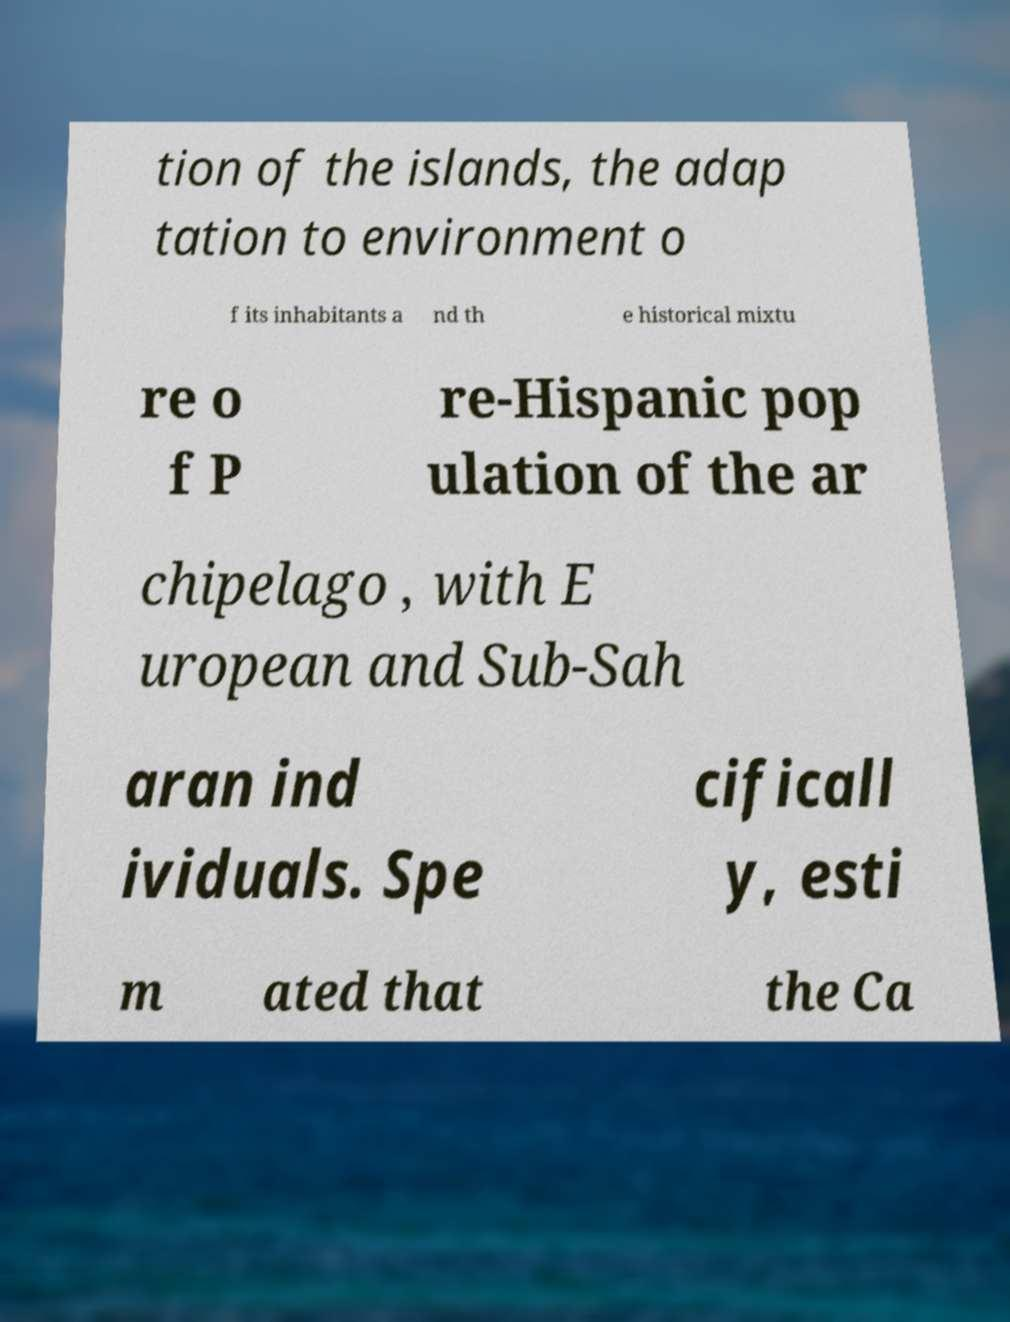I need the written content from this picture converted into text. Can you do that? tion of the islands, the adap tation to environment o f its inhabitants a nd th e historical mixtu re o f P re-Hispanic pop ulation of the ar chipelago , with E uropean and Sub-Sah aran ind ividuals. Spe cificall y, esti m ated that the Ca 